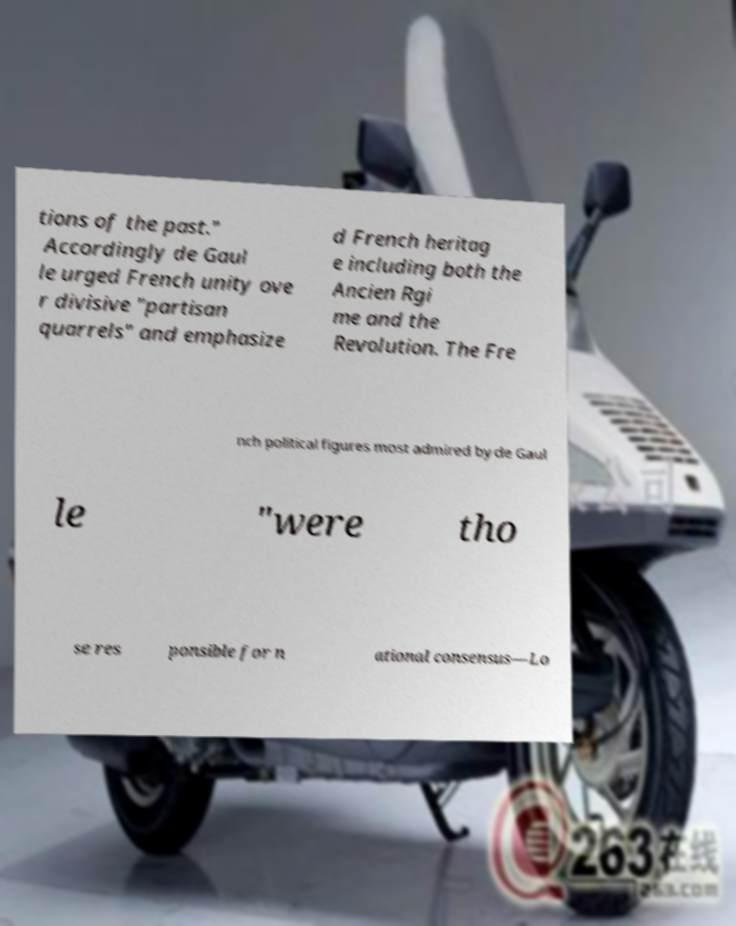Please read and relay the text visible in this image. What does it say? tions of the past." Accordingly de Gaul le urged French unity ove r divisive "partisan quarrels" and emphasize d French heritag e including both the Ancien Rgi me and the Revolution. The Fre nch political figures most admired by de Gaul le "were tho se res ponsible for n ational consensus—Lo 